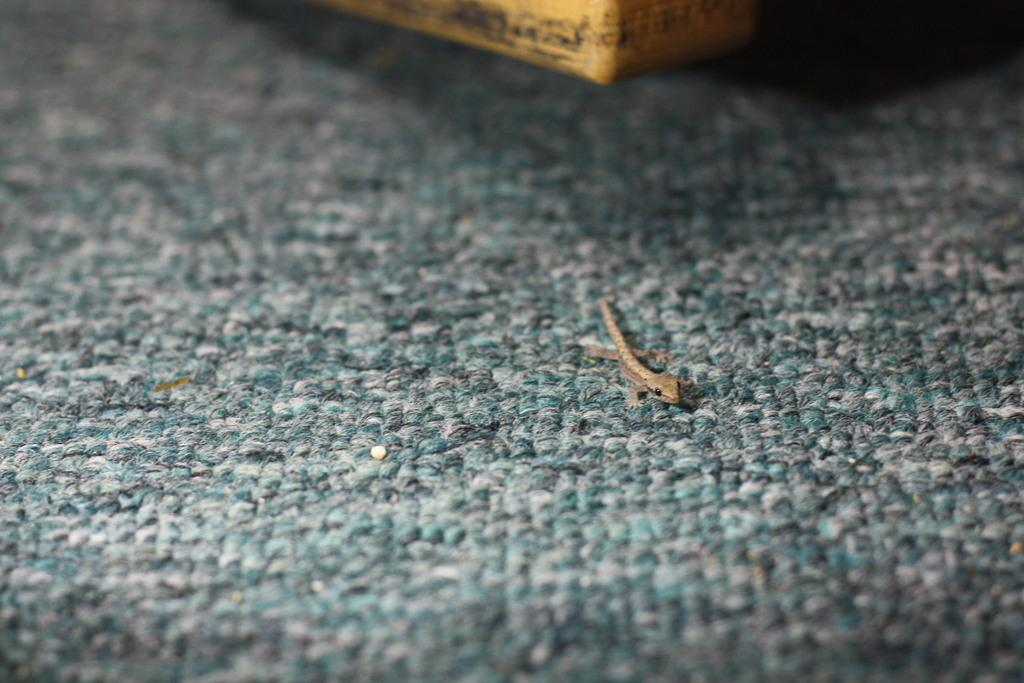What type of animal can be seen on the floor in the image? There is a lizard present on the floor in the image. What is the lizard doing in the image? The provided facts do not specify what the lizard is doing in the image. Can you describe the lizard's appearance in the image? The provided facts do not specify the lizard's appearance in the image. How many pizzas are being served by the slave in the image? There is no slave or pizza present in the image; it only features a lizard on the floor. 